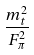Convert formula to latex. <formula><loc_0><loc_0><loc_500><loc_500>\frac { m _ { t } ^ { 2 } } { F _ { \pi } ^ { 2 } }</formula> 